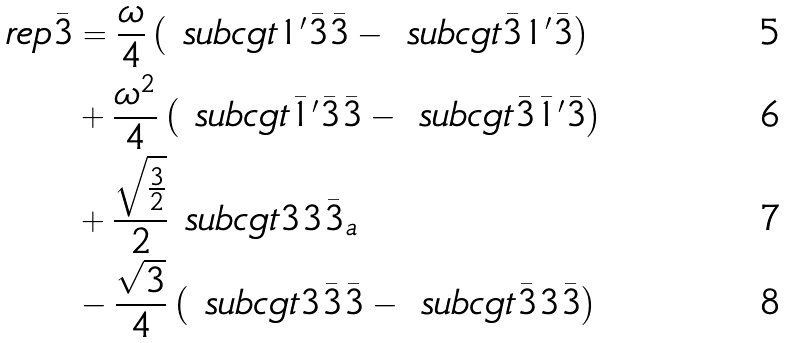Convert formula to latex. <formula><loc_0><loc_0><loc_500><loc_500>\ r e p { \bar { 3 } } & = \frac { \omega } { 4 } \left ( \ s u b c g t { 1 ^ { \prime } } { \bar { 3 } } { \bar { 3 } } - \ s u b c g t { \bar { 3 } } { 1 ^ { \prime } } { \bar { 3 } } \right ) \\ & + \frac { \omega ^ { 2 } } { 4 } \left ( \ s u b c g t { \bar { 1 } ^ { \prime } } { \bar { 3 } } { \bar { 3 } } - \ s u b c g t { \bar { 3 } } { \bar { 1 } ^ { \prime } } { \bar { 3 } } \right ) \\ & + \frac { \sqrt { \frac { 3 } { 2 } } } { 2 } \ s u b c g t { 3 } { 3 } { \bar { 3 } _ { a } } \\ & - \frac { \sqrt { 3 } } { 4 } \left ( \ s u b c g t { 3 } { \bar { 3 } } { \bar { 3 } } - \ s u b c g t { \bar { 3 } } { 3 } { \bar { 3 } } \right )</formula> 